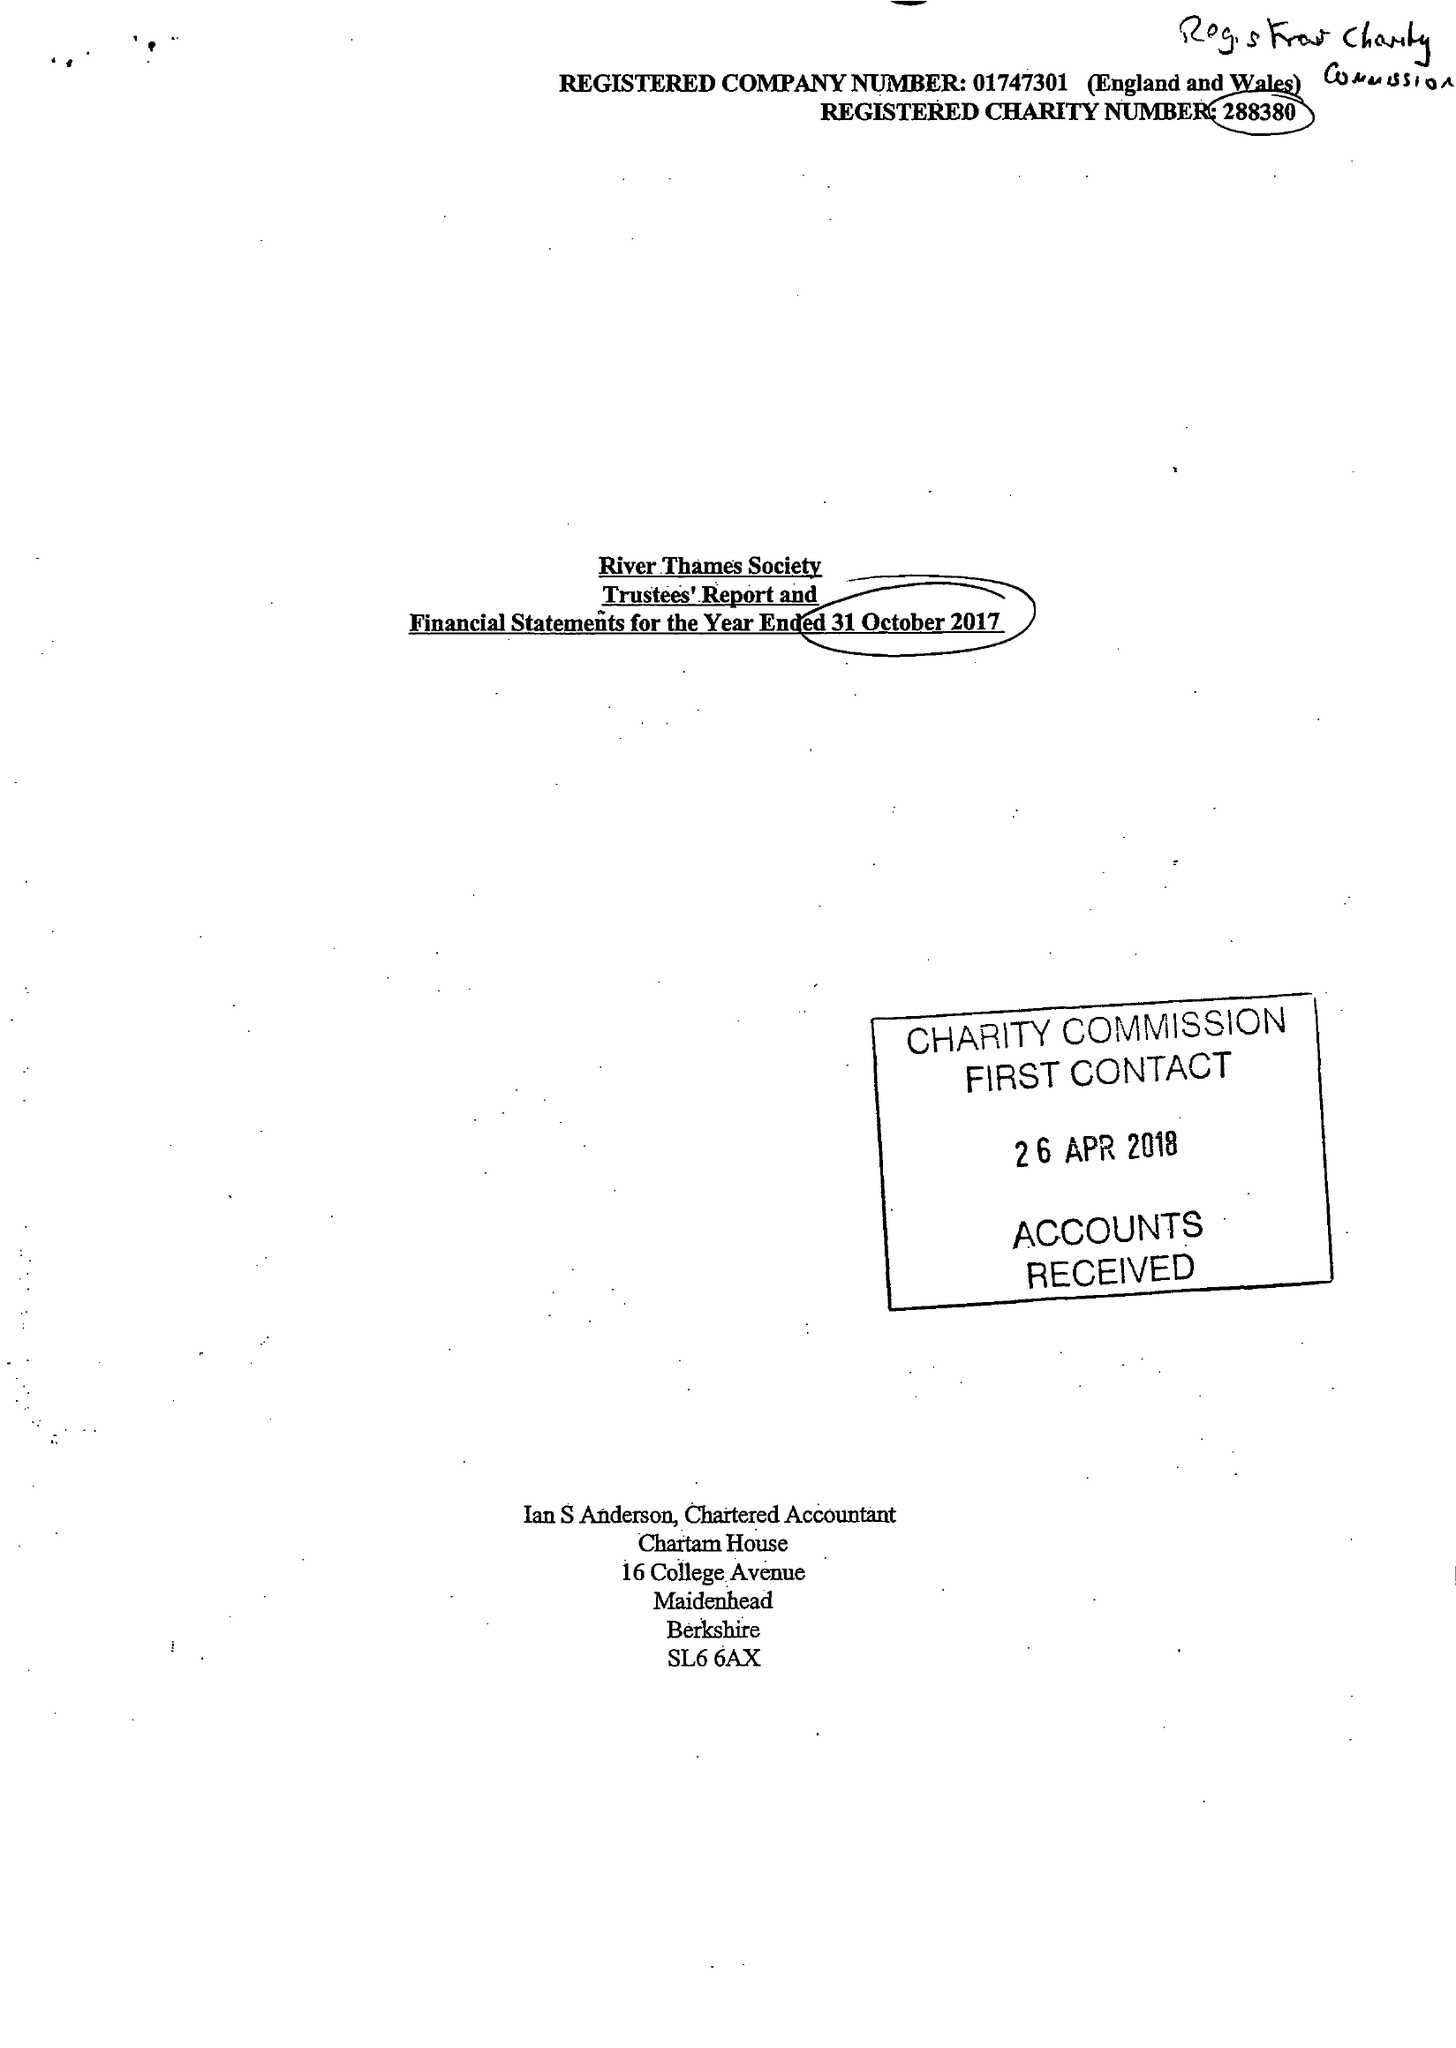What is the value for the charity_number?
Answer the question using a single word or phrase. 288380 